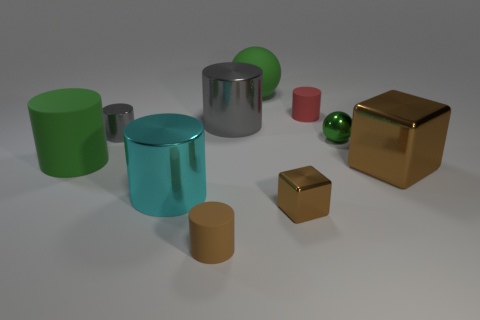Subtract 2 cylinders. How many cylinders are left? 4 Subtract all cyan cylinders. How many cylinders are left? 5 Subtract all cyan cylinders. How many cylinders are left? 5 Subtract all red cylinders. Subtract all green blocks. How many cylinders are left? 5 Subtract all cubes. How many objects are left? 8 Add 8 small green metallic objects. How many small green metallic objects are left? 9 Add 3 green rubber balls. How many green rubber balls exist? 4 Subtract 1 cyan cylinders. How many objects are left? 9 Subtract all small red things. Subtract all brown rubber cylinders. How many objects are left? 8 